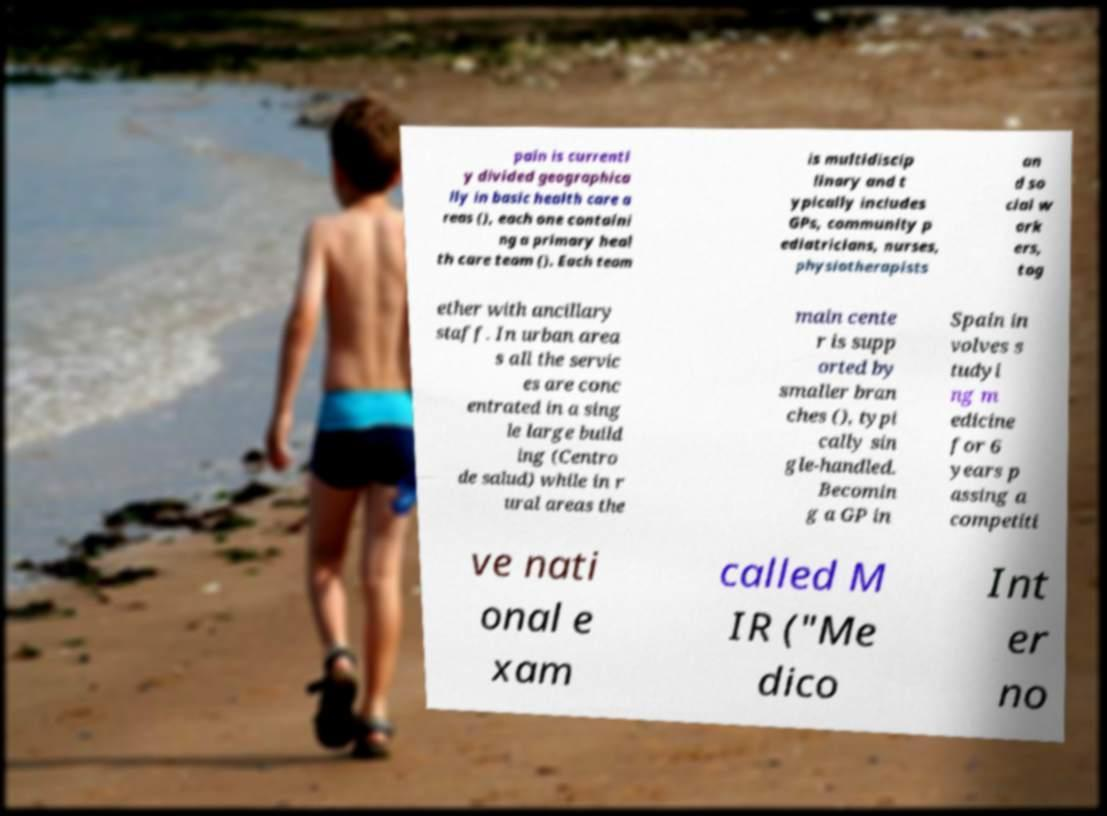There's text embedded in this image that I need extracted. Can you transcribe it verbatim? pain is currentl y divided geographica lly in basic health care a reas (), each one containi ng a primary heal th care team (). Each team is multidiscip linary and t ypically includes GPs, community p ediatricians, nurses, physiotherapists an d so cial w ork ers, tog ether with ancillary staff. In urban area s all the servic es are conc entrated in a sing le large build ing (Centro de salud) while in r ural areas the main cente r is supp orted by smaller bran ches (), typi cally sin gle-handled. Becomin g a GP in Spain in volves s tudyi ng m edicine for 6 years p assing a competiti ve nati onal e xam called M IR ("Me dico Int er no 